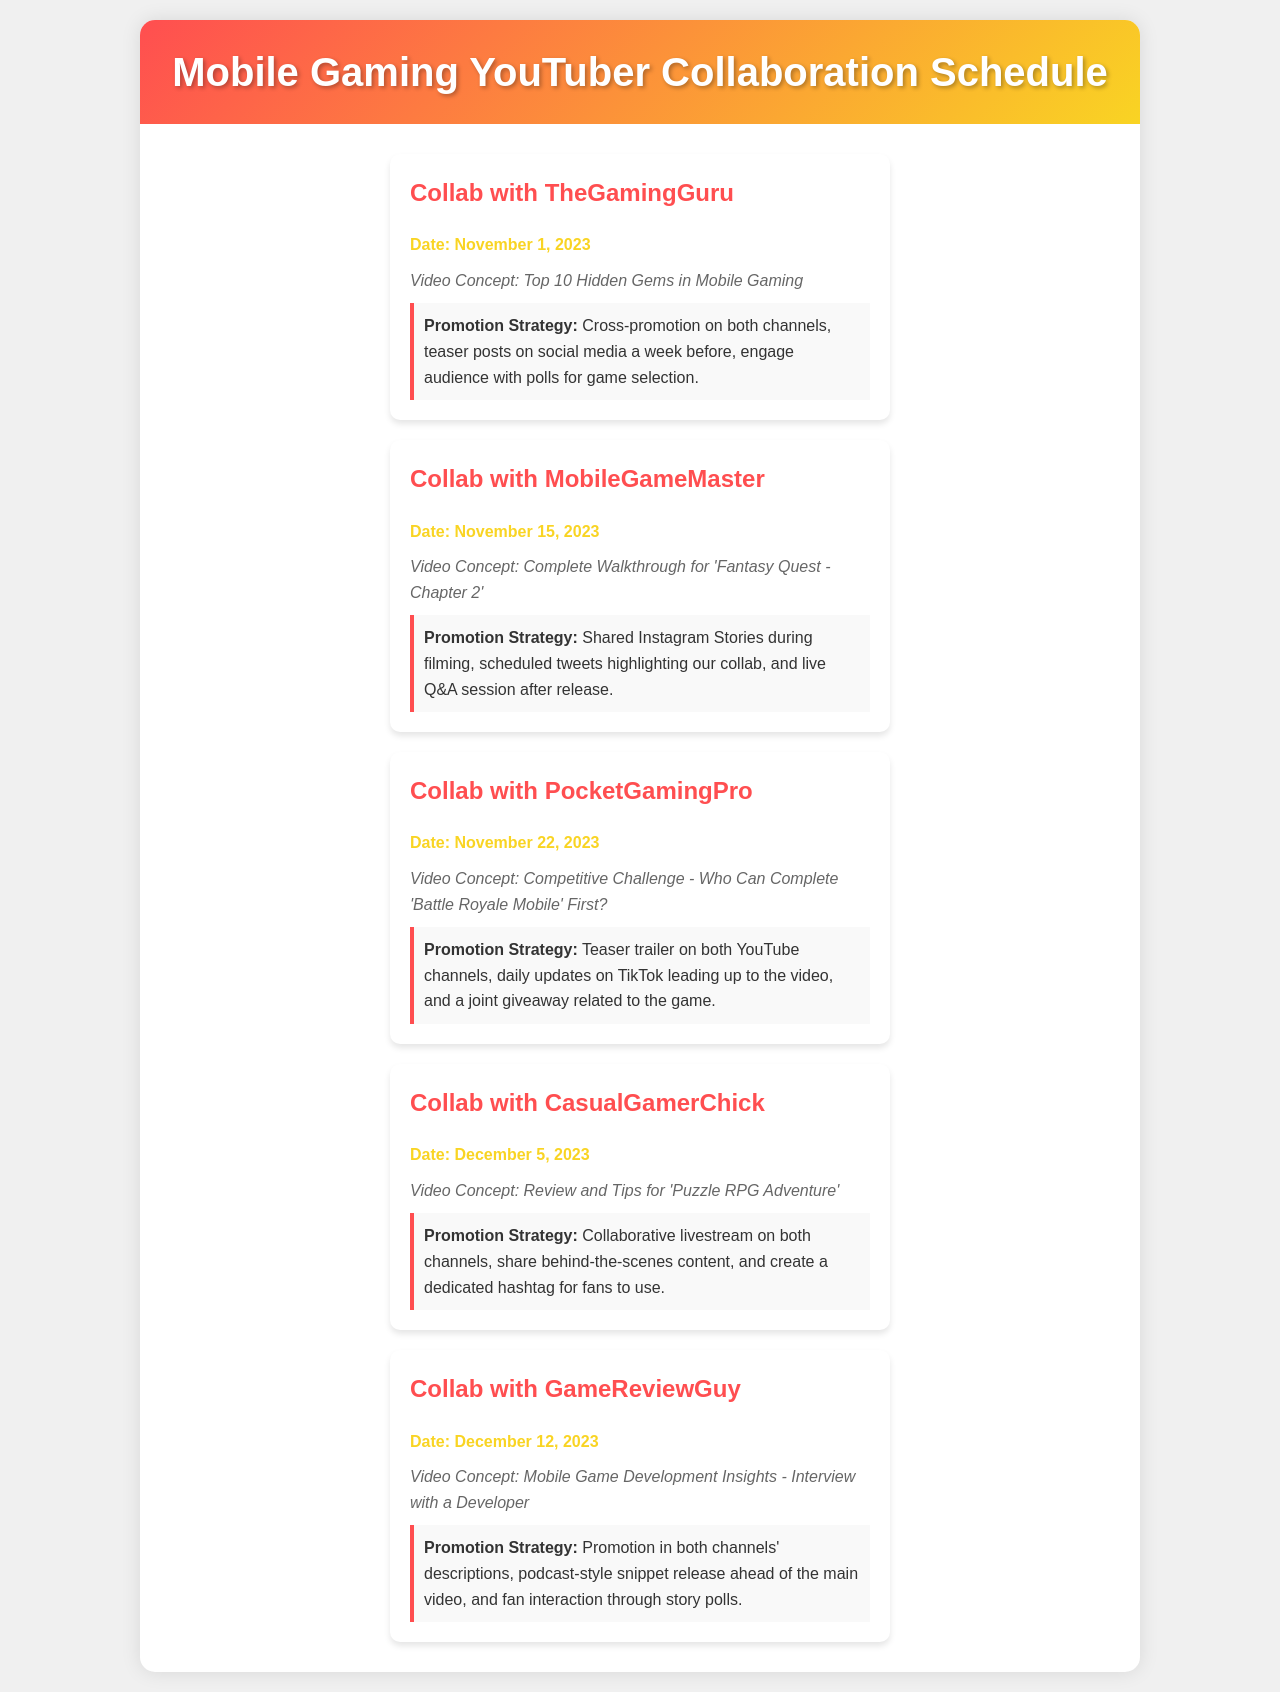What is the date of the collab with TheGamingGuru? The document specifies that the collab with TheGamingGuru is scheduled for November 1, 2023.
Answer: November 1, 2023 What is the video concept for the collaboration with MobileGameMaster? According to the document, the video concept for the collaboration with MobileGameMaster is "Complete Walkthrough for 'Fantasy Quest - Chapter 2'."
Answer: Complete Walkthrough for 'Fantasy Quest - Chapter 2' What promotion strategy is planned for the collab with PocketGamingPro? The document states the promotion strategy for this collaboration includes a teaser trailer on both YouTube channels.
Answer: Teaser trailer on both YouTube channels How many days are between the collabs with MobileGameMaster and PocketGamingPro? The schedule shows that the collab with MobileGameMaster is on November 15, 2023, and PocketGamingPro is on November 22, 2023, which is a gap of 7 days.
Answer: 7 days What is a planned activity for promoting the video with CasualGamerChick? The document describes a collaborative livestream on both channels as a promotion strategy for the video with CasualGamerChick.
Answer: Collaborative livestream on both channels 